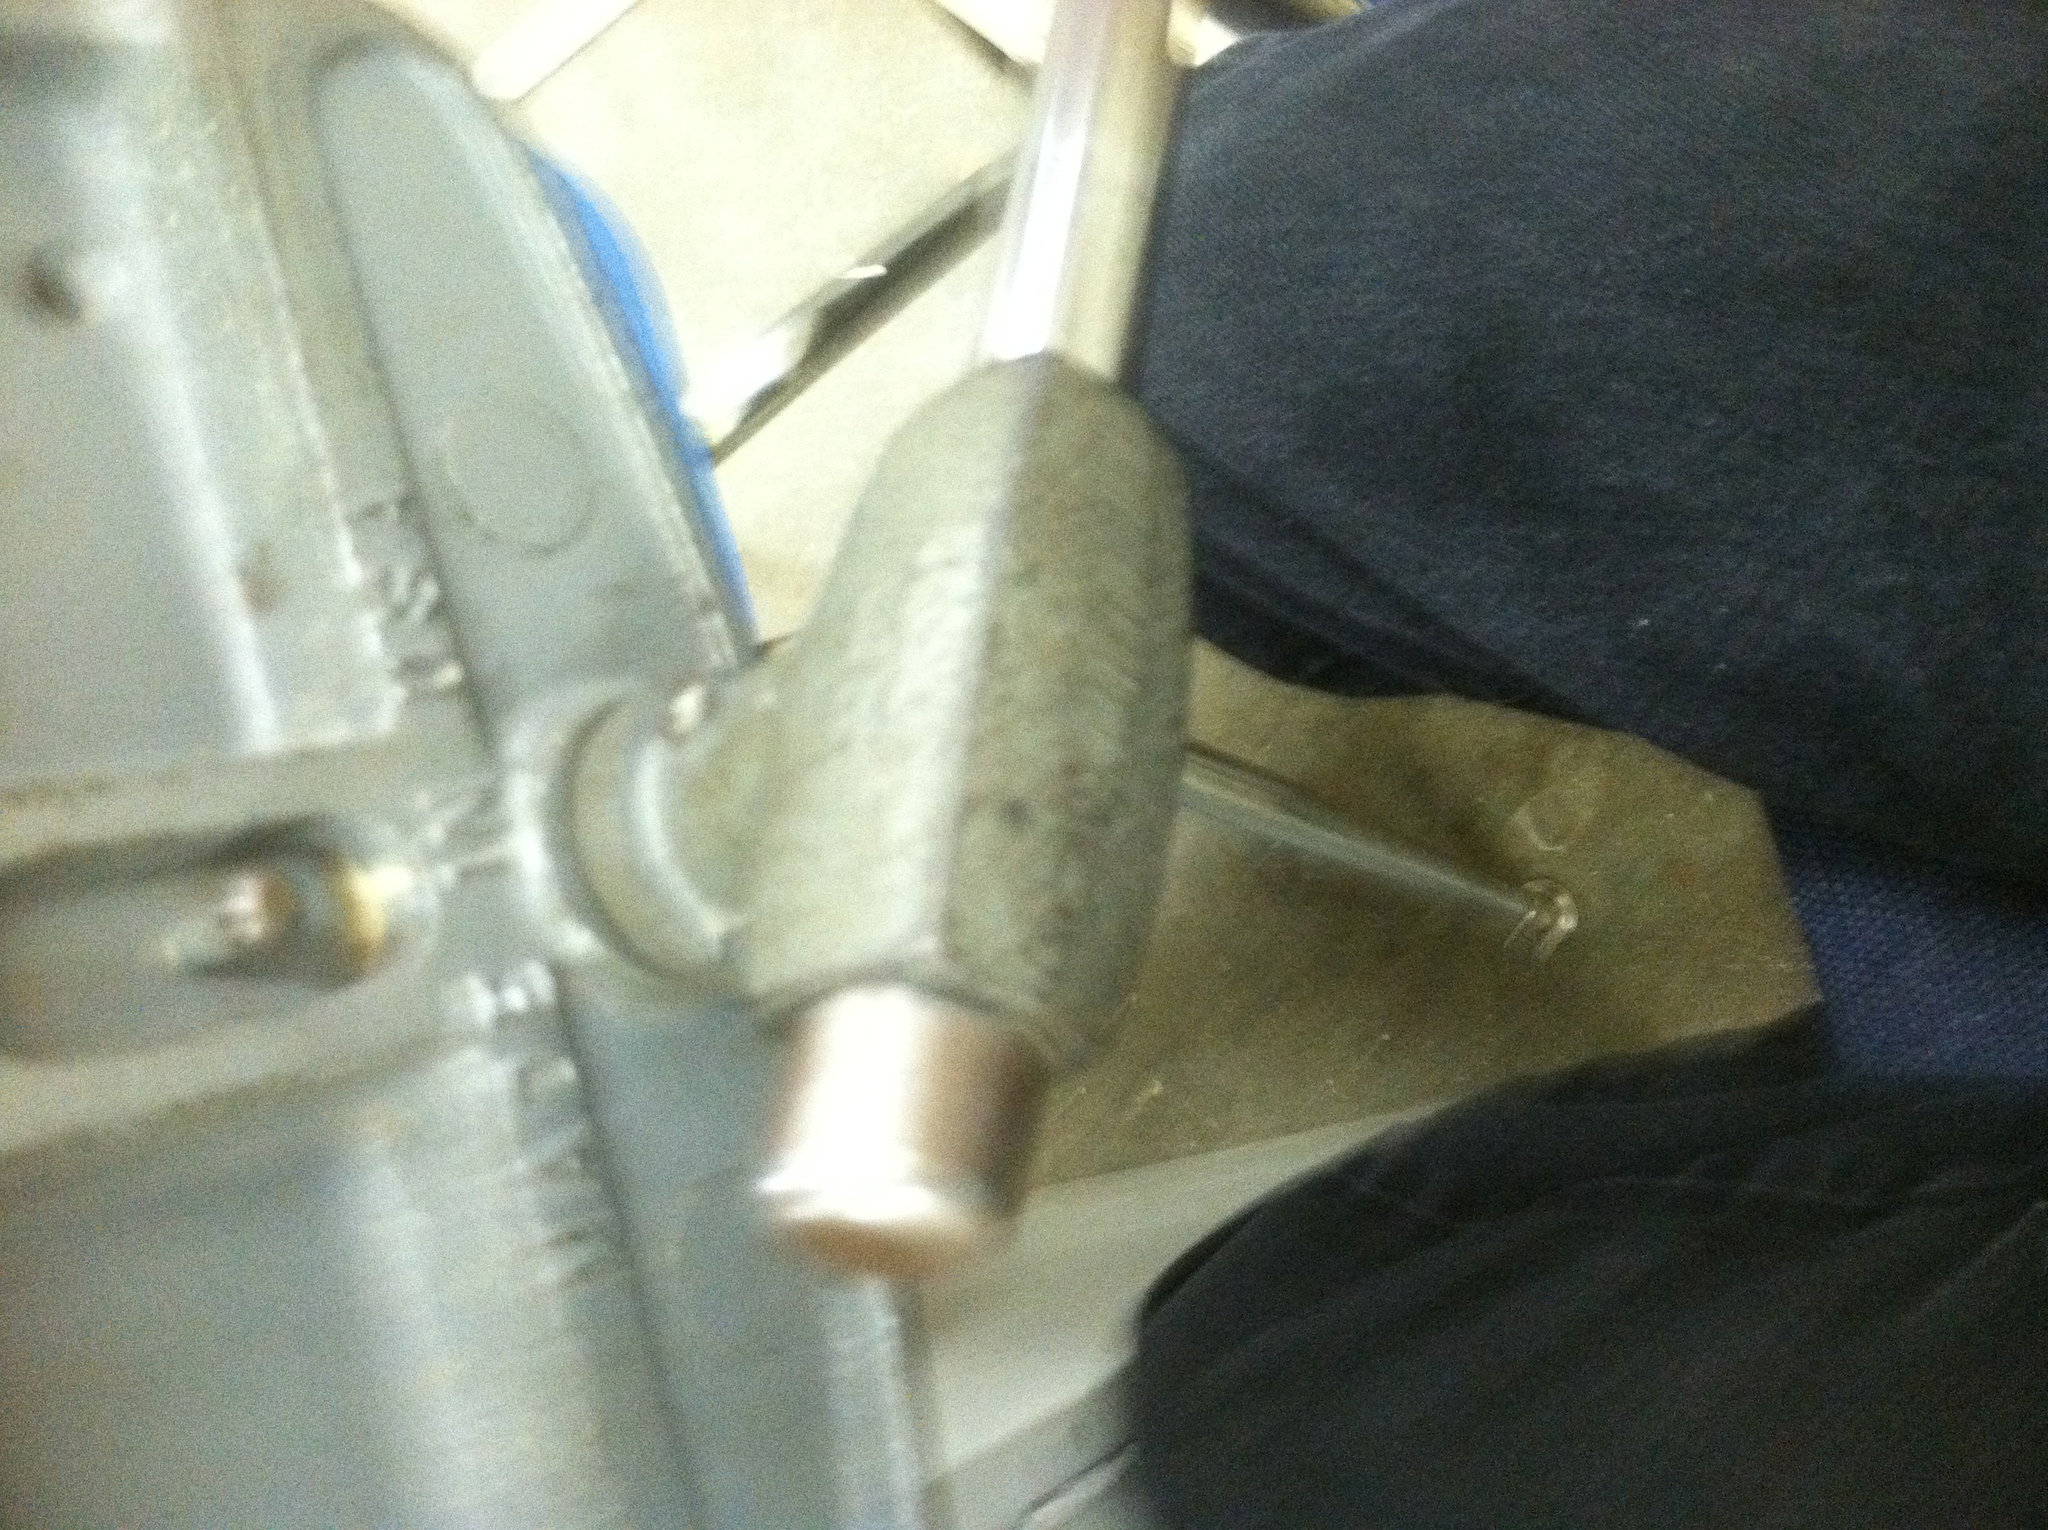Imagine this vise was used in a futuristic workshop. What kind of advanced features might it have? In a futuristic workshop, this vise could have several advanced features. It might incorporate smart technology, such as sensors to detect the pressure applied and adjust automatically to prevent damage to the object. It could have a digital interface to set and monitor pressure, with alerts for optimal settings. The vise might also feature materials that adapt their shape to different objects, ensuring a perfect fit every time. Can you give an example of a project that could benefit from such an advanced vise? Sure! Imagine working on a delicate piece of machinery, like a custom-made drone. Using the advanced vise, you can securely hold various components of the drone without worrying about damaging them. The smart technology would ensure that each part is held with the right amount of pressure, and the digital interface would help you monitor and adjust settings throughout the assembly process. This would allow for high precision and prevent any mishaps, resulting in a perfectly assembled drone. 